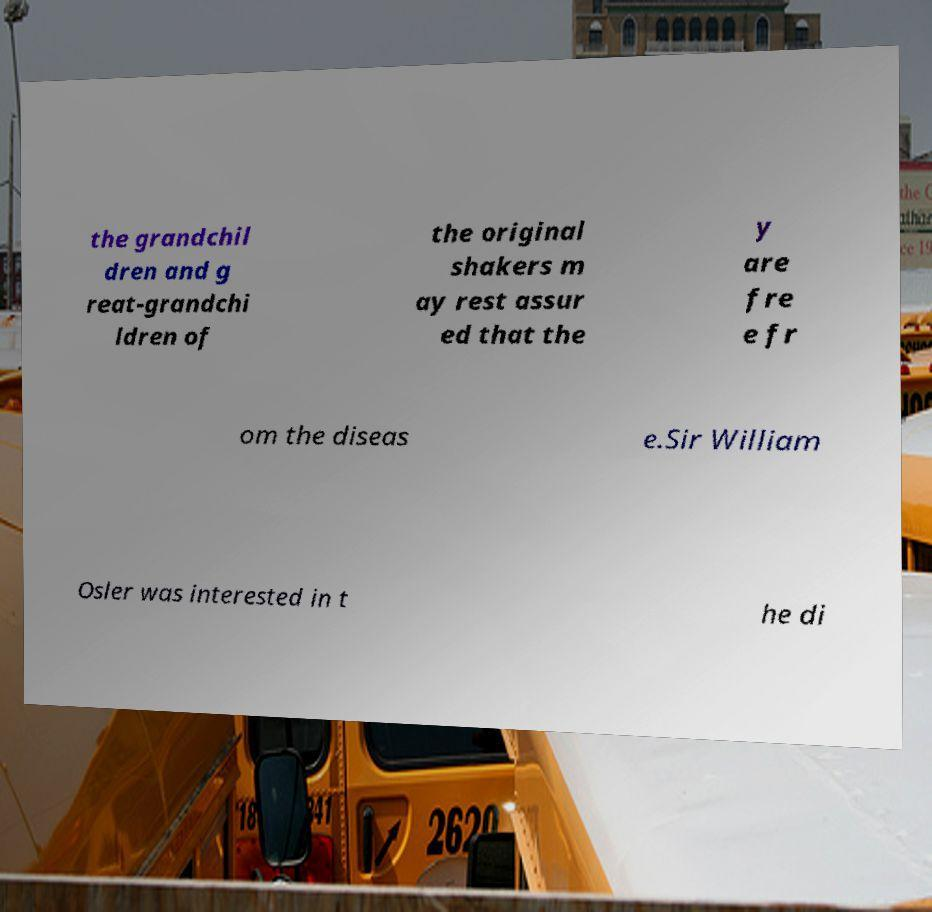Please read and relay the text visible in this image. What does it say? the grandchil dren and g reat-grandchi ldren of the original shakers m ay rest assur ed that the y are fre e fr om the diseas e.Sir William Osler was interested in t he di 